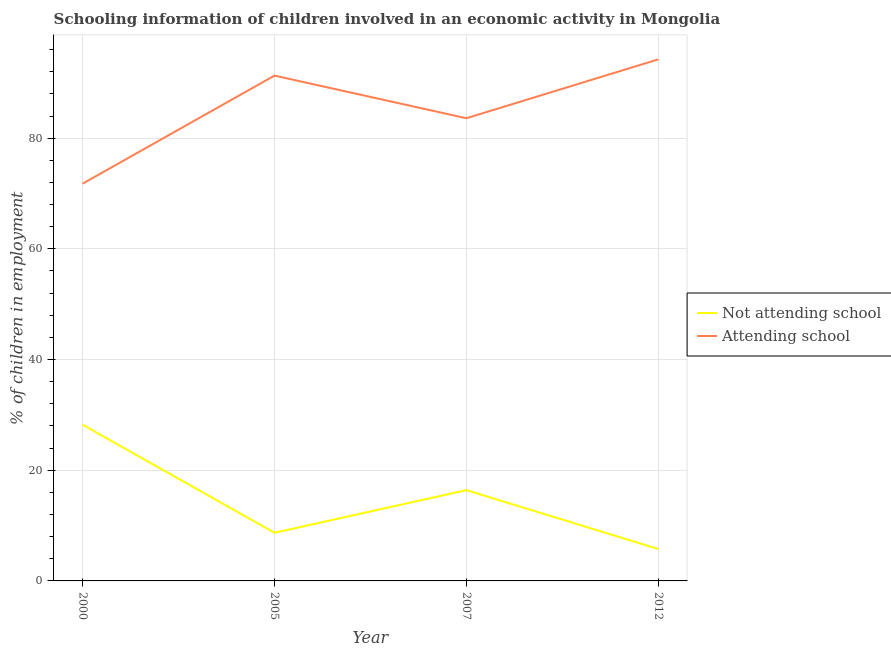How many different coloured lines are there?
Provide a succinct answer. 2. Does the line corresponding to percentage of employed children who are not attending school intersect with the line corresponding to percentage of employed children who are attending school?
Provide a succinct answer. No. What is the percentage of employed children who are not attending school in 2000?
Offer a terse response. 28.23. Across all years, what is the maximum percentage of employed children who are not attending school?
Make the answer very short. 28.23. Across all years, what is the minimum percentage of employed children who are not attending school?
Your answer should be very brief. 5.76. In which year was the percentage of employed children who are not attending school maximum?
Keep it short and to the point. 2000. In which year was the percentage of employed children who are not attending school minimum?
Make the answer very short. 2012. What is the total percentage of employed children who are not attending school in the graph?
Make the answer very short. 59.09. What is the difference between the percentage of employed children who are attending school in 2000 and that in 2012?
Your answer should be very brief. -22.47. What is the difference between the percentage of employed children who are attending school in 2012 and the percentage of employed children who are not attending school in 2007?
Your response must be concise. 77.84. What is the average percentage of employed children who are not attending school per year?
Your answer should be compact. 14.77. In the year 2005, what is the difference between the percentage of employed children who are not attending school and percentage of employed children who are attending school?
Your response must be concise. -82.6. In how many years, is the percentage of employed children who are not attending school greater than 60 %?
Your answer should be very brief. 0. What is the ratio of the percentage of employed children who are attending school in 2005 to that in 2007?
Offer a terse response. 1.09. Is the percentage of employed children who are not attending school in 2005 less than that in 2007?
Provide a succinct answer. Yes. What is the difference between the highest and the second highest percentage of employed children who are attending school?
Ensure brevity in your answer.  2.94. What is the difference between the highest and the lowest percentage of employed children who are attending school?
Give a very brief answer. 22.47. In how many years, is the percentage of employed children who are attending school greater than the average percentage of employed children who are attending school taken over all years?
Offer a very short reply. 2. Is the percentage of employed children who are attending school strictly less than the percentage of employed children who are not attending school over the years?
Your response must be concise. No. How many lines are there?
Keep it short and to the point. 2. How many years are there in the graph?
Offer a terse response. 4. What is the difference between two consecutive major ticks on the Y-axis?
Keep it short and to the point. 20. Does the graph contain any zero values?
Ensure brevity in your answer.  No. Where does the legend appear in the graph?
Your answer should be compact. Center right. How are the legend labels stacked?
Ensure brevity in your answer.  Vertical. What is the title of the graph?
Offer a very short reply. Schooling information of children involved in an economic activity in Mongolia. Does "Private credit bureau" appear as one of the legend labels in the graph?
Your answer should be very brief. No. What is the label or title of the X-axis?
Your answer should be compact. Year. What is the label or title of the Y-axis?
Your answer should be compact. % of children in employment. What is the % of children in employment of Not attending school in 2000?
Provide a succinct answer. 28.23. What is the % of children in employment of Attending school in 2000?
Keep it short and to the point. 71.77. What is the % of children in employment of Attending school in 2005?
Your response must be concise. 91.3. What is the % of children in employment in Attending school in 2007?
Ensure brevity in your answer.  83.6. What is the % of children in employment of Not attending school in 2012?
Ensure brevity in your answer.  5.76. What is the % of children in employment in Attending school in 2012?
Ensure brevity in your answer.  94.24. Across all years, what is the maximum % of children in employment in Not attending school?
Your answer should be very brief. 28.23. Across all years, what is the maximum % of children in employment of Attending school?
Offer a terse response. 94.24. Across all years, what is the minimum % of children in employment in Not attending school?
Offer a terse response. 5.76. Across all years, what is the minimum % of children in employment of Attending school?
Offer a terse response. 71.77. What is the total % of children in employment of Not attending school in the graph?
Keep it short and to the point. 59.09. What is the total % of children in employment in Attending school in the graph?
Provide a succinct answer. 340.91. What is the difference between the % of children in employment of Not attending school in 2000 and that in 2005?
Keep it short and to the point. 19.53. What is the difference between the % of children in employment of Attending school in 2000 and that in 2005?
Provide a short and direct response. -19.53. What is the difference between the % of children in employment of Not attending school in 2000 and that in 2007?
Your answer should be compact. 11.83. What is the difference between the % of children in employment of Attending school in 2000 and that in 2007?
Offer a terse response. -11.83. What is the difference between the % of children in employment of Not attending school in 2000 and that in 2012?
Offer a very short reply. 22.47. What is the difference between the % of children in employment of Attending school in 2000 and that in 2012?
Offer a very short reply. -22.47. What is the difference between the % of children in employment in Not attending school in 2005 and that in 2007?
Provide a succinct answer. -7.7. What is the difference between the % of children in employment of Attending school in 2005 and that in 2007?
Your response must be concise. 7.7. What is the difference between the % of children in employment in Not attending school in 2005 and that in 2012?
Give a very brief answer. 2.94. What is the difference between the % of children in employment in Attending school in 2005 and that in 2012?
Make the answer very short. -2.94. What is the difference between the % of children in employment of Not attending school in 2007 and that in 2012?
Your answer should be compact. 10.64. What is the difference between the % of children in employment in Attending school in 2007 and that in 2012?
Provide a succinct answer. -10.64. What is the difference between the % of children in employment in Not attending school in 2000 and the % of children in employment in Attending school in 2005?
Your response must be concise. -63.07. What is the difference between the % of children in employment in Not attending school in 2000 and the % of children in employment in Attending school in 2007?
Your answer should be compact. -55.37. What is the difference between the % of children in employment of Not attending school in 2000 and the % of children in employment of Attending school in 2012?
Your answer should be very brief. -66.01. What is the difference between the % of children in employment of Not attending school in 2005 and the % of children in employment of Attending school in 2007?
Your response must be concise. -74.9. What is the difference between the % of children in employment of Not attending school in 2005 and the % of children in employment of Attending school in 2012?
Keep it short and to the point. -85.54. What is the difference between the % of children in employment in Not attending school in 2007 and the % of children in employment in Attending school in 2012?
Offer a very short reply. -77.84. What is the average % of children in employment in Not attending school per year?
Provide a short and direct response. 14.77. What is the average % of children in employment of Attending school per year?
Make the answer very short. 85.23. In the year 2000, what is the difference between the % of children in employment in Not attending school and % of children in employment in Attending school?
Offer a terse response. -43.55. In the year 2005, what is the difference between the % of children in employment of Not attending school and % of children in employment of Attending school?
Offer a terse response. -82.6. In the year 2007, what is the difference between the % of children in employment in Not attending school and % of children in employment in Attending school?
Offer a very short reply. -67.2. In the year 2012, what is the difference between the % of children in employment of Not attending school and % of children in employment of Attending school?
Keep it short and to the point. -88.48. What is the ratio of the % of children in employment of Not attending school in 2000 to that in 2005?
Your response must be concise. 3.24. What is the ratio of the % of children in employment in Attending school in 2000 to that in 2005?
Your answer should be compact. 0.79. What is the ratio of the % of children in employment in Not attending school in 2000 to that in 2007?
Your answer should be compact. 1.72. What is the ratio of the % of children in employment of Attending school in 2000 to that in 2007?
Your answer should be very brief. 0.86. What is the ratio of the % of children in employment in Not attending school in 2000 to that in 2012?
Ensure brevity in your answer.  4.9. What is the ratio of the % of children in employment in Attending school in 2000 to that in 2012?
Make the answer very short. 0.76. What is the ratio of the % of children in employment in Not attending school in 2005 to that in 2007?
Provide a succinct answer. 0.53. What is the ratio of the % of children in employment in Attending school in 2005 to that in 2007?
Your answer should be very brief. 1.09. What is the ratio of the % of children in employment in Not attending school in 2005 to that in 2012?
Your answer should be compact. 1.51. What is the ratio of the % of children in employment in Attending school in 2005 to that in 2012?
Your response must be concise. 0.97. What is the ratio of the % of children in employment in Not attending school in 2007 to that in 2012?
Make the answer very short. 2.85. What is the ratio of the % of children in employment in Attending school in 2007 to that in 2012?
Offer a very short reply. 0.89. What is the difference between the highest and the second highest % of children in employment of Not attending school?
Provide a short and direct response. 11.83. What is the difference between the highest and the second highest % of children in employment in Attending school?
Keep it short and to the point. 2.94. What is the difference between the highest and the lowest % of children in employment of Not attending school?
Your response must be concise. 22.47. What is the difference between the highest and the lowest % of children in employment of Attending school?
Your answer should be very brief. 22.47. 